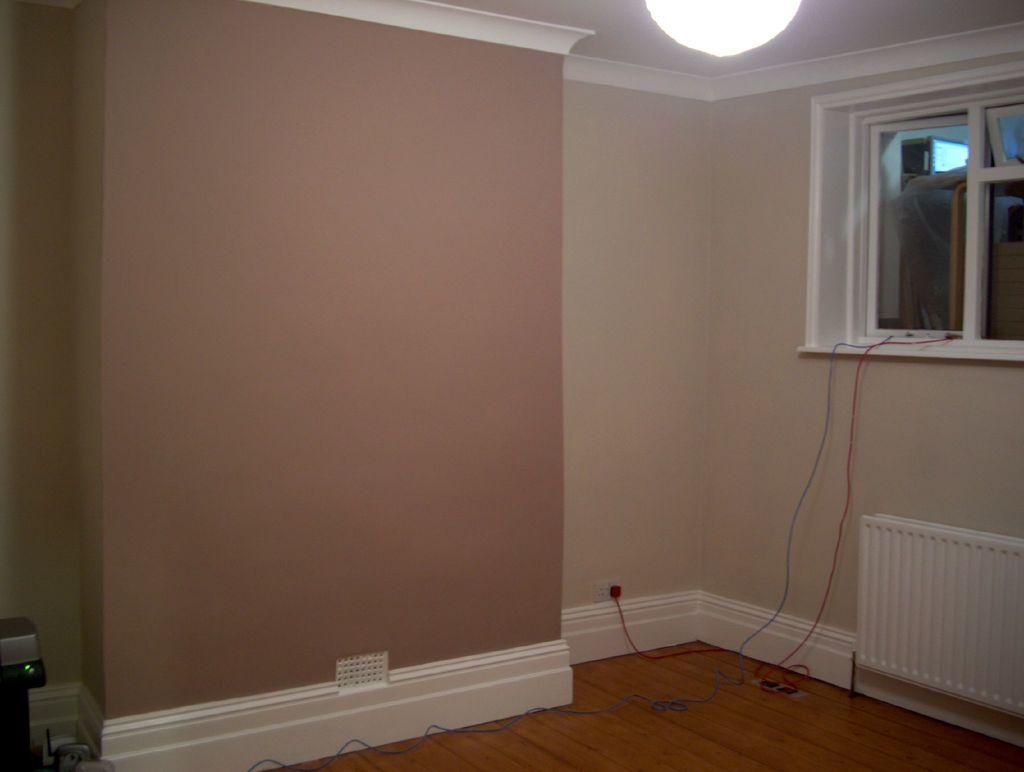In one or two sentences, can you explain what this image depicts? In this image I can see the inner part of the room, background I can see the glass window, a light and the wall is in cream and brown color. 